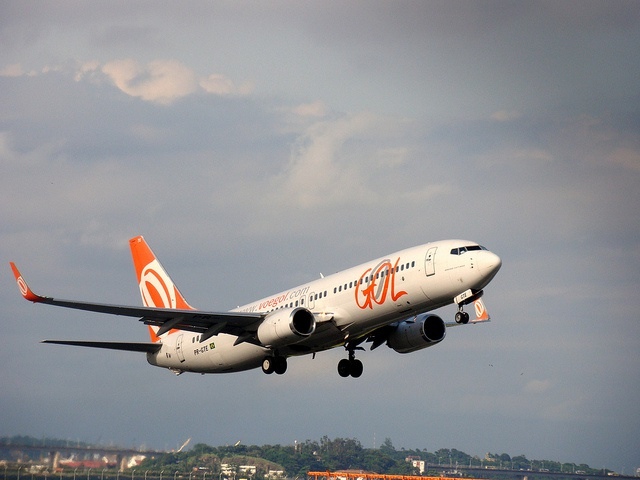Describe the objects in this image and their specific colors. I can see a airplane in gray, black, beige, darkgray, and tan tones in this image. 